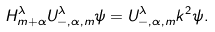Convert formula to latex. <formula><loc_0><loc_0><loc_500><loc_500>H _ { m + \alpha } ^ { \lambda } U _ { - , \alpha , m } ^ { \lambda } \psi = U _ { - , \alpha , m } ^ { \lambda } k ^ { 2 } \psi .</formula> 